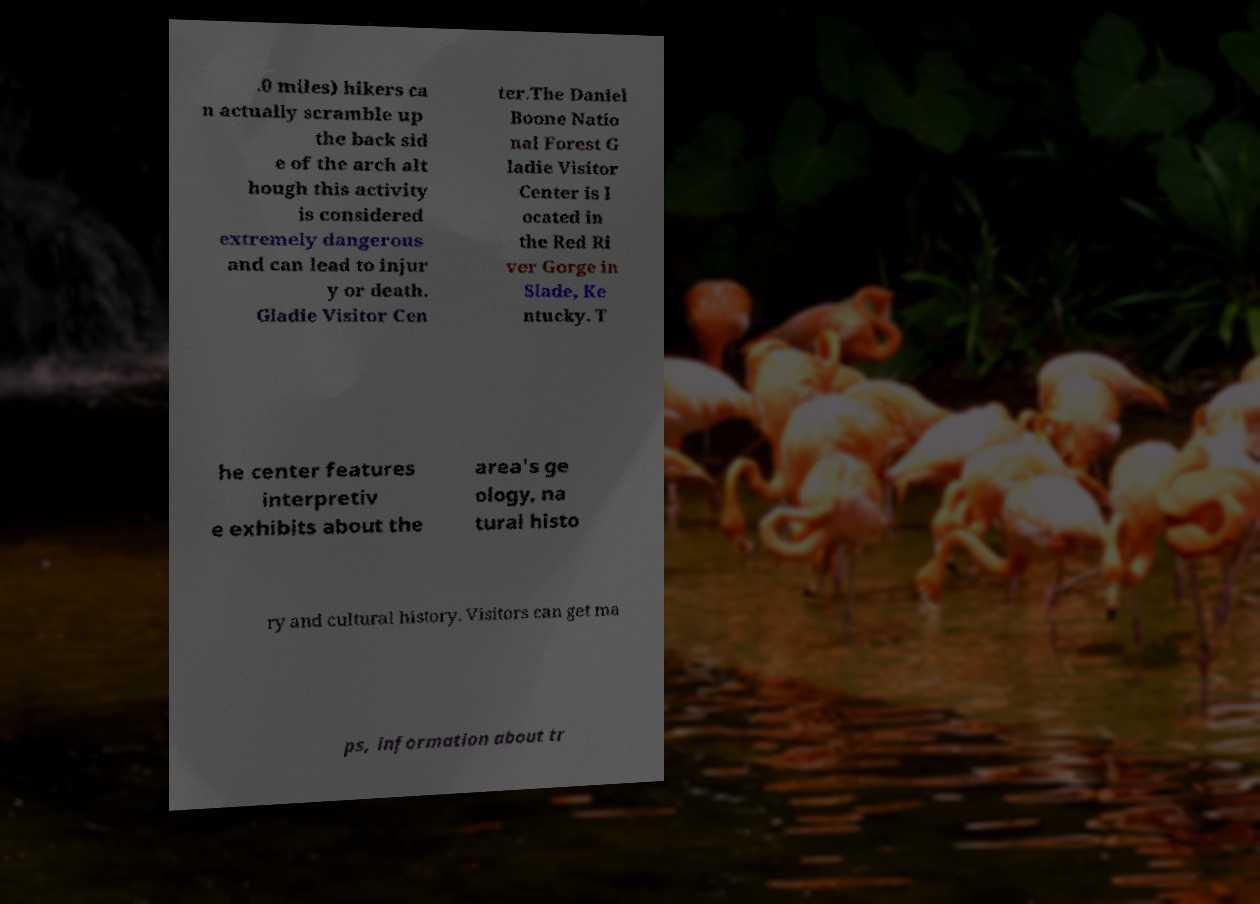Please identify and transcribe the text found in this image. .0 miles) hikers ca n actually scramble up the back sid e of the arch alt hough this activity is considered extremely dangerous and can lead to injur y or death. Gladie Visitor Cen ter.The Daniel Boone Natio nal Forest G ladie Visitor Center is l ocated in the Red Ri ver Gorge in Slade, Ke ntucky. T he center features interpretiv e exhibits about the area's ge ology, na tural histo ry and cultural history. Visitors can get ma ps, information about tr 